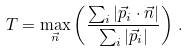<formula> <loc_0><loc_0><loc_500><loc_500>T = \max _ { \vec { n } } \left ( \frac { \sum _ { i } | \vec { p } _ { i } \cdot \vec { n } | } { \sum _ { i } | \vec { p } _ { i } | } \right ) \, .</formula> 